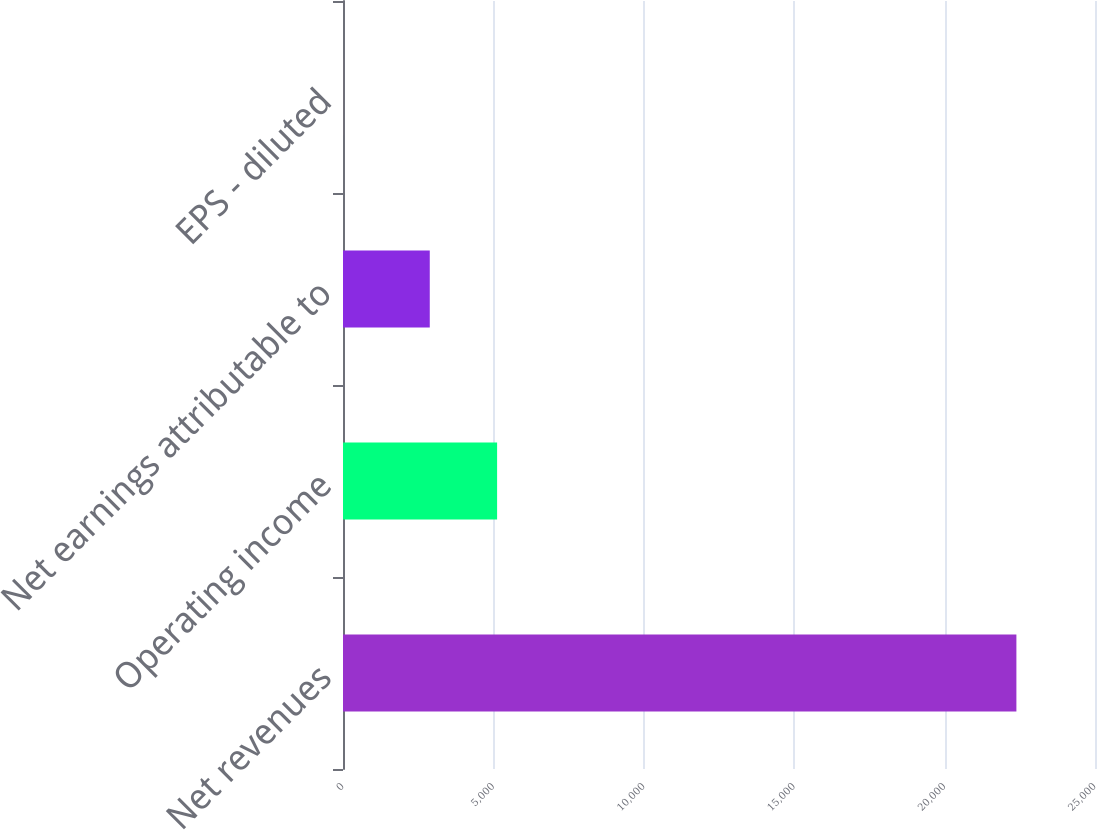<chart> <loc_0><loc_0><loc_500><loc_500><bar_chart><fcel>Net revenues<fcel>Operating income<fcel>Net earnings attributable to<fcel>EPS - diluted<nl><fcel>22386.8<fcel>5123.18<fcel>2884.7<fcel>1.97<nl></chart> 